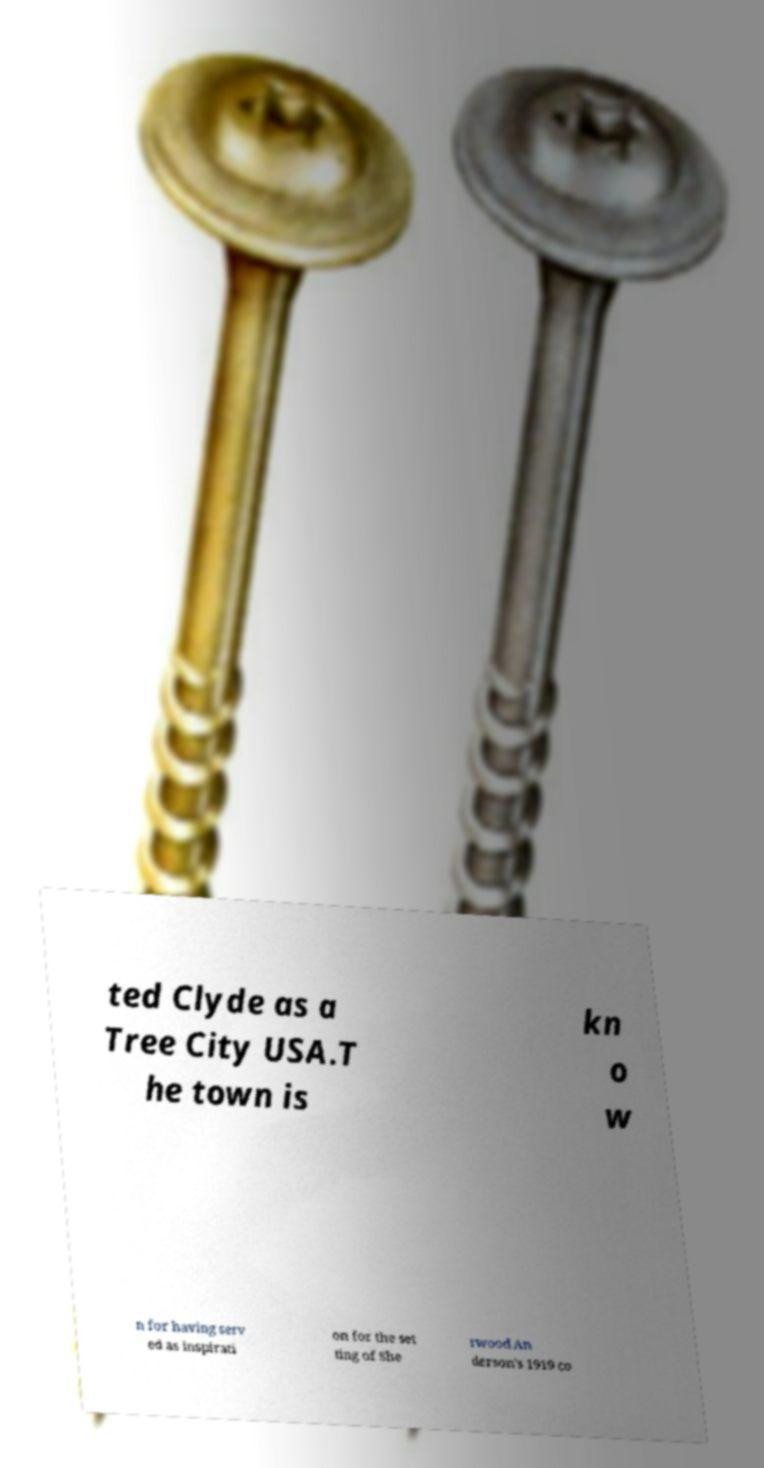I need the written content from this picture converted into text. Can you do that? ted Clyde as a Tree City USA.T he town is kn o w n for having serv ed as inspirati on for the set ting of She rwood An derson's 1919 co 